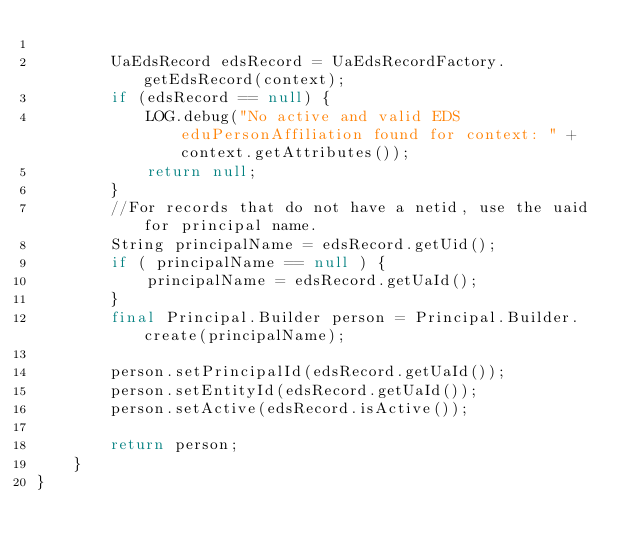<code> <loc_0><loc_0><loc_500><loc_500><_Java_>
		UaEdsRecord edsRecord = UaEdsRecordFactory.getEdsRecord(context);
		if (edsRecord == null) {
			LOG.debug("No active and valid EDS eduPersonAffiliation found for context: " + context.getAttributes());
			return null;
		}
		//For records that do not have a netid, use the uaid for principal name.
		String principalName = edsRecord.getUid();
		if ( principalName == null ) {
			principalName = edsRecord.getUaId();
		}
		final Principal.Builder person = Principal.Builder.create(principalName);

		person.setPrincipalId(edsRecord.getUaId());
		person.setEntityId(edsRecord.getUaId());
		person.setActive(edsRecord.isActive());

		return person;
	}
}
</code> 